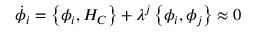<formula> <loc_0><loc_0><loc_500><loc_500>\dot { \phi } _ { i } = \left \{ \phi _ { i } , H _ { C } \right \} + \lambda ^ { j } \left \{ \phi _ { i } , \phi _ { j } \right \} \approx 0</formula> 